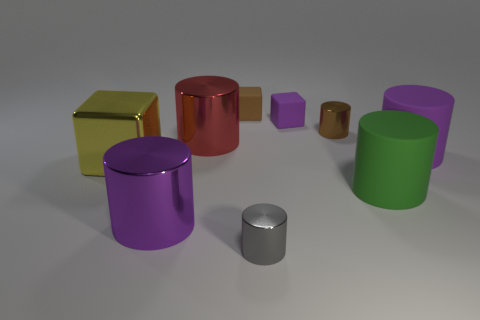Are there any metallic things?
Provide a short and direct response. Yes. Are there more large yellow shiny objects that are in front of the tiny purple cube than large yellow metallic cubes right of the large yellow thing?
Keep it short and to the point. Yes. There is a purple object that is both in front of the big red object and behind the big green matte object; what is its material?
Your response must be concise. Rubber. Is the brown matte object the same shape as the big yellow metal thing?
Your answer should be very brief. Yes. What number of yellow cubes are behind the green object?
Your answer should be compact. 1. Is the size of the purple thing in front of the yellow object the same as the brown block?
Provide a succinct answer. No. There is another big shiny object that is the same shape as the big red metallic thing; what color is it?
Your answer should be compact. Purple. There is a purple matte thing behind the brown metal cylinder; what shape is it?
Make the answer very short. Cube. What number of large purple shiny objects have the same shape as the tiny gray object?
Your answer should be very brief. 1. Is the color of the tiny cube that is in front of the brown matte object the same as the big rubber cylinder that is on the right side of the large green object?
Offer a terse response. Yes. 